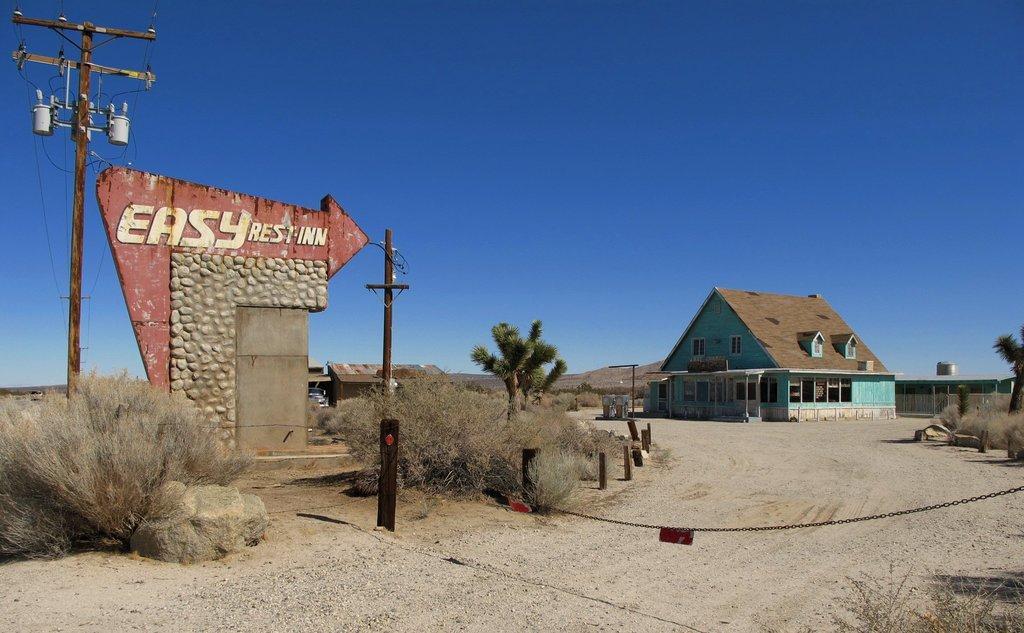Could you give a brief overview of what you see in this image? In this image, I can see the current poles, plants, trees, houses, wall with text and a rock. On the right side of the image, I can see an iron chain. In the background, there is the sky. 